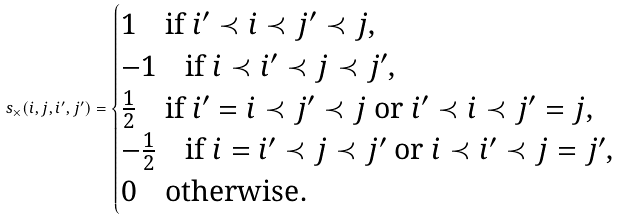Convert formula to latex. <formula><loc_0><loc_0><loc_500><loc_500>s _ { \times } ( i , j , i ^ { \prime } , j ^ { \prime } ) = \begin{cases} 1 \quad \text {if $i^{\prime}\prec i\prec j^{\prime}\prec j$} , \\ - 1 \quad \text {if $i\prec i^{\prime}\prec j\prec j^{\prime}$} , \\ \frac { 1 } { 2 } \quad \text {if $i^{\prime}=i\prec j^{\prime}\prec j$ or $i^{\prime}\prec i\prec j^{\prime}=j$} , \\ - \frac { 1 } { 2 } \quad \text {if $i=i^{\prime}\prec j\prec j^{\prime}$ or $i\prec i^{\prime}\prec j=j^{\prime}$} , \\ 0 \quad \text {otherwise} . \end{cases}</formula> 